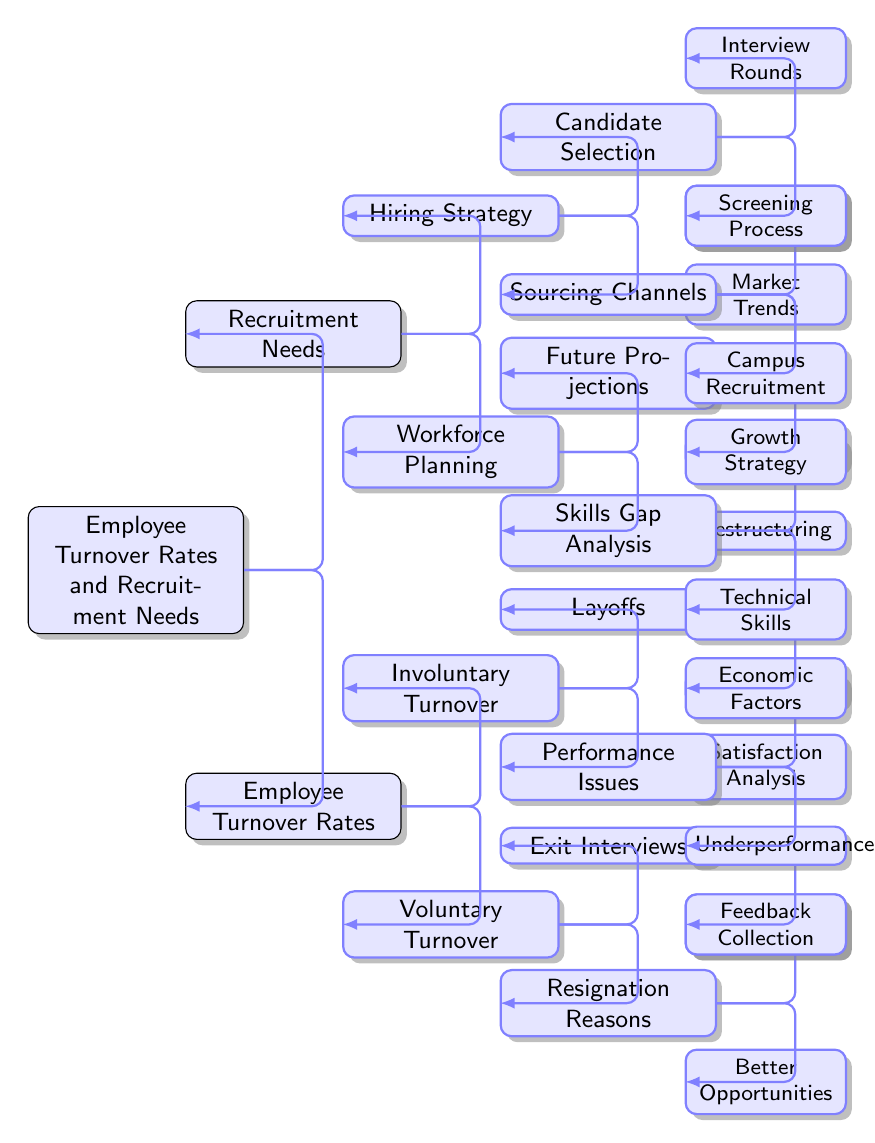What is the main topic of the diagram? The main topic is located at the top of the diagram and is clearly labeled as "Employee Turnover Rates and Recruitment Needs." This is the overarching theme that everything else branches from.
Answer: Employee Turnover Rates and Recruitment Needs How many categories are under Employee Turnover Rates? From the diagram, there are two clear children of the "Employee Turnover Rates": "Voluntary Turnover" and "Involuntary Turnover." Counting them provides this answer.
Answer: 2 What are the subcategories under Voluntary Turnover? The node representing "Voluntary Turnover" has two child nodes: "Resignation Reasons" and "Exit Interviews." These represent the areas of focus within voluntary turnover.
Answer: Resignation Reasons, Exit Interviews What are the reasons for resignation listed in the diagram? Under the "Resignation Reasons" node, there are two child nodes: "Better Opportunities" and "Work-Life Balance." These provide specific reasons why employees may choose to resign voluntarily.
Answer: Better Opportunities, Work-Life Balance Which two aspects are analyzed under Skills Gap Analysis? The "Skills Gap Analysis" node lists two specific analyses: "Technical Skills" and "Soft Skills." These represent the focus areas for analyzing skill deficiencies within the workforce.
Answer: Technical Skills, Soft Skills What two factors contribute to Layoffs as mentioned in the diagram? The "Layoffs" node has two child nodes, which indicate contributing factors: "Economic Factors" and "Restructuring." These factors explain the reasons for layoffs in the organization.
Answer: Economic Factors, Restructuring What is the focus of the Future Projections node? The "Future Projections" node has two children: "Growth Strategy" and "Market Trends." These areas are essential for planning future recruitment needs based on projected changes.
Answer: Growth Strategy, Market Trends What are the two sourcing channels listed under Hiring Strategy? The "Sourcing Channels" node under "Hiring Strategy" outlines two channels: "Campus Recruitment" and "Online Job Portals." These indicate different methods for sourcing candidates.
Answer: Campus Recruitment, Online Job Portals Which components belong to the Candidate Selection process? The "Candidate Selection" node has two elements: "Screening Process" and "Interview Rounds." These describe the stages of selecting candidates during recruitment.
Answer: Screening Process, Interview Rounds 